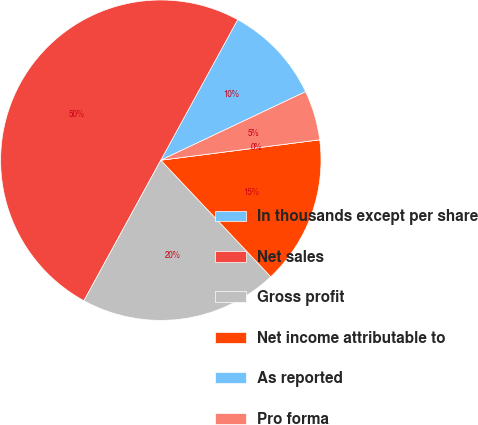Convert chart to OTSL. <chart><loc_0><loc_0><loc_500><loc_500><pie_chart><fcel>In thousands except per share<fcel>Net sales<fcel>Gross profit<fcel>Net income attributable to<fcel>As reported<fcel>Pro forma<nl><fcel>10.0%<fcel>50.0%<fcel>20.0%<fcel>15.0%<fcel>0.0%<fcel>5.0%<nl></chart> 